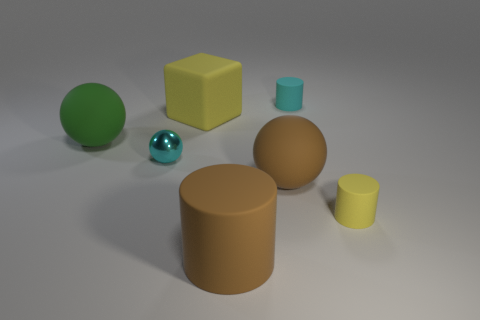Subtract all big brown spheres. How many spheres are left? 2 Add 2 metallic balls. How many objects exist? 9 Subtract all yellow cylinders. How many cylinders are left? 2 Subtract all spheres. How many objects are left? 4 Subtract 1 cylinders. How many cylinders are left? 2 Subtract all gray blocks. Subtract all blue spheres. How many blocks are left? 1 Subtract 0 gray blocks. How many objects are left? 7 Subtract all cyan spheres. How many blue cylinders are left? 0 Subtract all yellow cubes. Subtract all tiny red things. How many objects are left? 6 Add 2 tiny yellow matte things. How many tiny yellow matte things are left? 3 